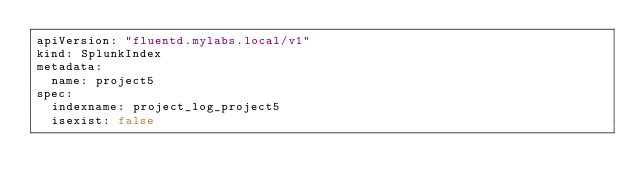<code> <loc_0><loc_0><loc_500><loc_500><_YAML_>apiVersion: "fluentd.mylabs.local/v1"
kind: SplunkIndex
metadata:
  name: project5
spec:
  indexname: project_log_project5
  isexist: false
</code> 